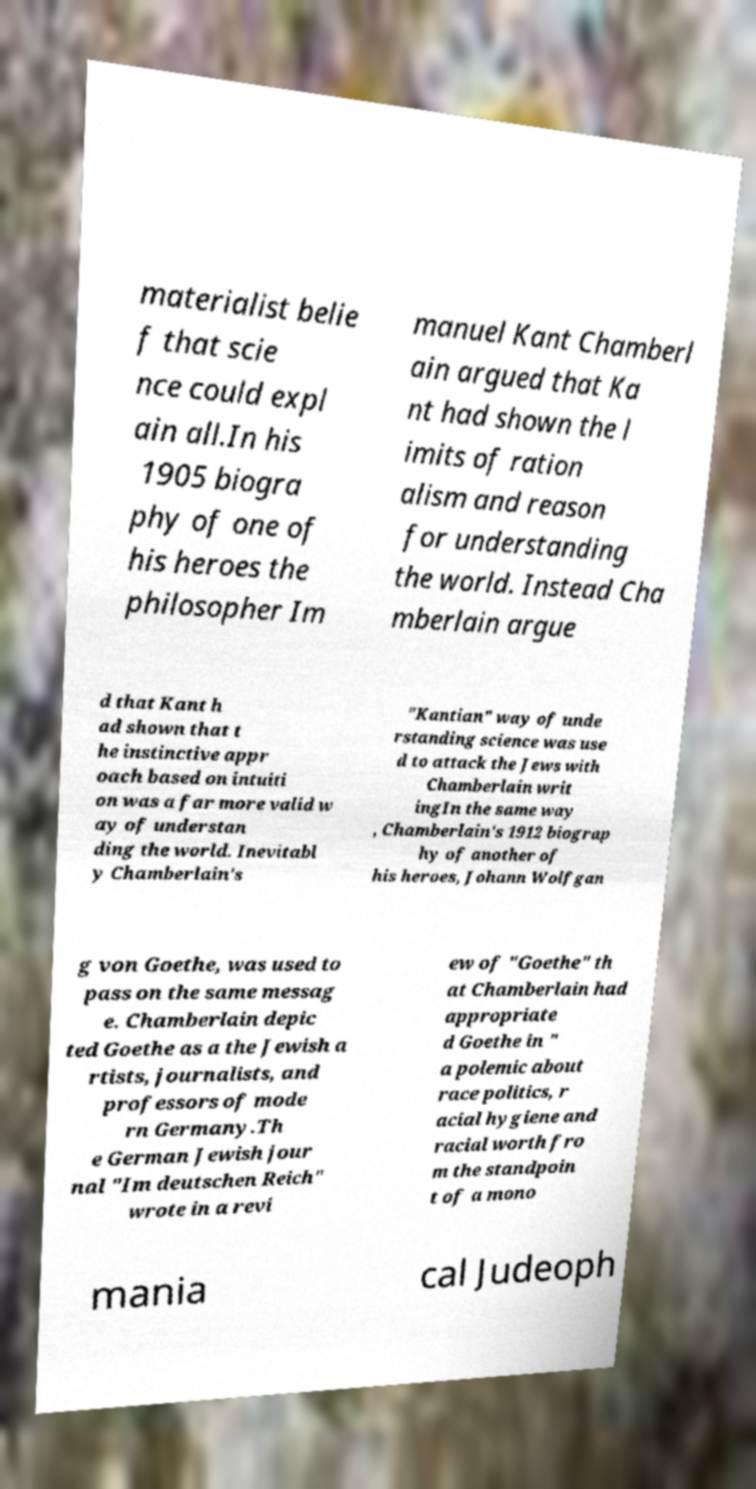Please identify and transcribe the text found in this image. materialist belie f that scie nce could expl ain all.In his 1905 biogra phy of one of his heroes the philosopher Im manuel Kant Chamberl ain argued that Ka nt had shown the l imits of ration alism and reason for understanding the world. Instead Cha mberlain argue d that Kant h ad shown that t he instinctive appr oach based on intuiti on was a far more valid w ay of understan ding the world. Inevitabl y Chamberlain's "Kantian" way of unde rstanding science was use d to attack the Jews with Chamberlain writ ingIn the same way , Chamberlain's 1912 biograp hy of another of his heroes, Johann Wolfgan g von Goethe, was used to pass on the same messag e. Chamberlain depic ted Goethe as a the Jewish a rtists, journalists, and professors of mode rn Germany.Th e German Jewish jour nal "Im deutschen Reich" wrote in a revi ew of "Goethe" th at Chamberlain had appropriate d Goethe in " a polemic about race politics, r acial hygiene and racial worth fro m the standpoin t of a mono mania cal Judeoph 